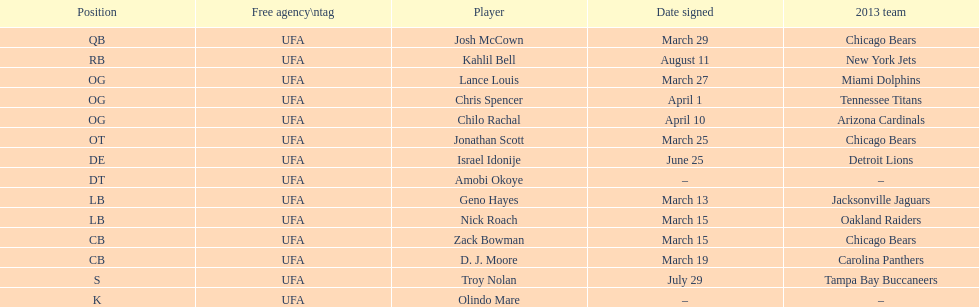How many players play cb or og? 5. 